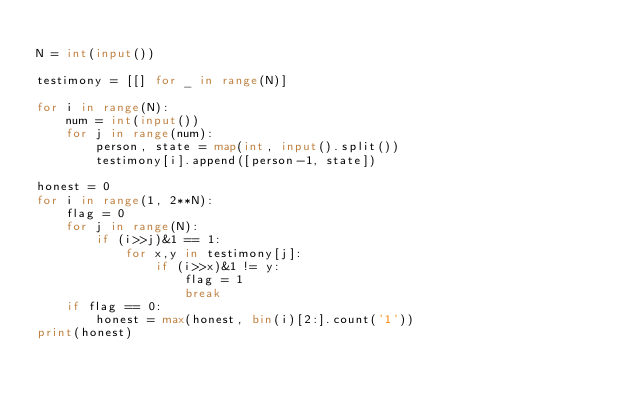<code> <loc_0><loc_0><loc_500><loc_500><_Python_>
N = int(input())
 
testimony = [[] for _ in range(N)]
 
for i in range(N):
    num = int(input())
    for j in range(num):
        person, state = map(int, input().split())
        testimony[i].append([person-1, state])
        
honest = 0
for i in range(1, 2**N):
    flag = 0
    for j in range(N):
        if (i>>j)&1 == 1: 
            for x,y in testimony[j]:
                if (i>>x)&1 != y: 
                    flag = 1
                    break
    if flag == 0: 
        honest = max(honest, bin(i)[2:].count('1')) 
print(honest)</code> 